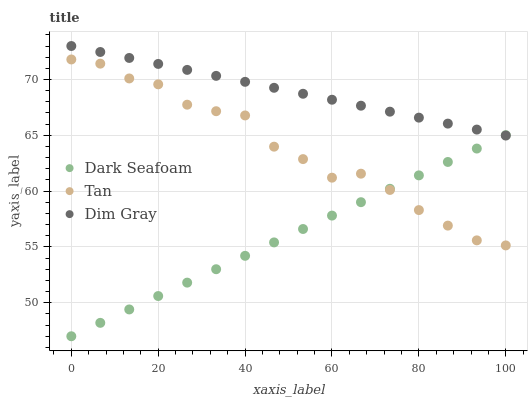Does Dark Seafoam have the minimum area under the curve?
Answer yes or no. Yes. Does Dim Gray have the maximum area under the curve?
Answer yes or no. Yes. Does Tan have the minimum area under the curve?
Answer yes or no. No. Does Tan have the maximum area under the curve?
Answer yes or no. No. Is Dark Seafoam the smoothest?
Answer yes or no. Yes. Is Tan the roughest?
Answer yes or no. Yes. Is Dim Gray the smoothest?
Answer yes or no. No. Is Dim Gray the roughest?
Answer yes or no. No. Does Dark Seafoam have the lowest value?
Answer yes or no. Yes. Does Tan have the lowest value?
Answer yes or no. No. Does Dim Gray have the highest value?
Answer yes or no. Yes. Does Tan have the highest value?
Answer yes or no. No. Is Tan less than Dim Gray?
Answer yes or no. Yes. Is Dim Gray greater than Tan?
Answer yes or no. Yes. Does Dark Seafoam intersect Tan?
Answer yes or no. Yes. Is Dark Seafoam less than Tan?
Answer yes or no. No. Is Dark Seafoam greater than Tan?
Answer yes or no. No. Does Tan intersect Dim Gray?
Answer yes or no. No. 